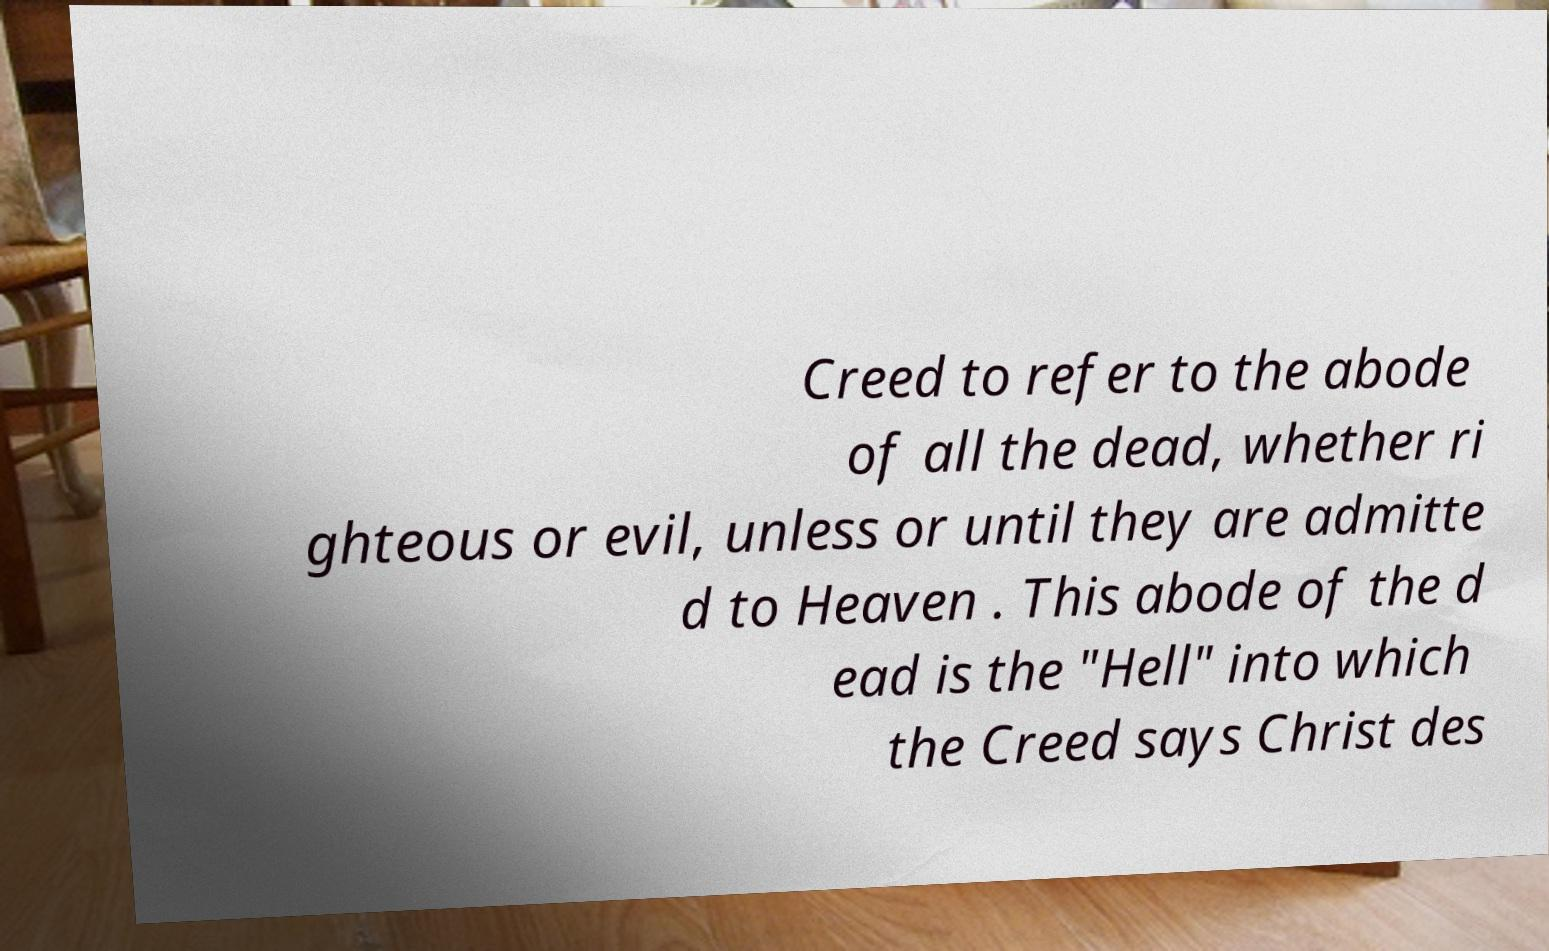Could you extract and type out the text from this image? Creed to refer to the abode of all the dead, whether ri ghteous or evil, unless or until they are admitte d to Heaven . This abode of the d ead is the "Hell" into which the Creed says Christ des 